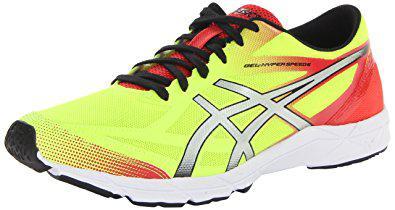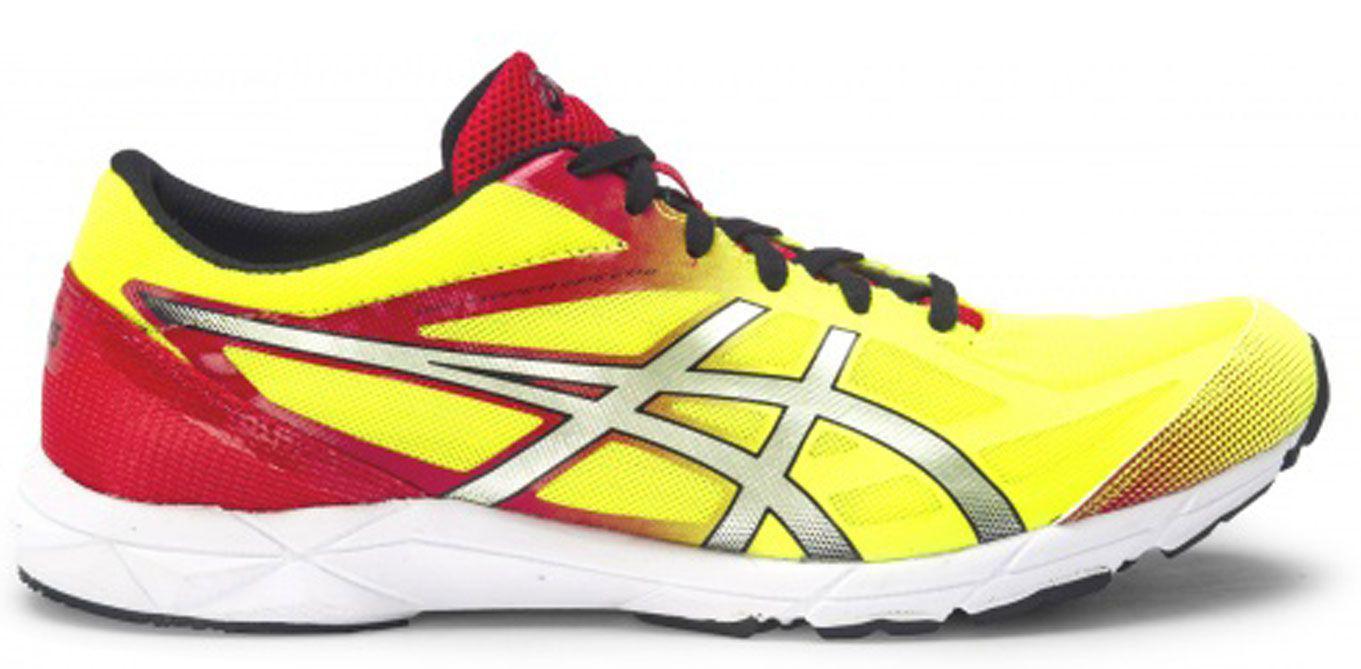The first image is the image on the left, the second image is the image on the right. Examine the images to the left and right. Is the description "The left image contains a sports show who's toe is facing towards the right." accurate? Answer yes or no. No. The first image is the image on the left, the second image is the image on the right. For the images displayed, is the sentence "Each image shows a single sneaker, and right and left images are posed heel to heel." factually correct? Answer yes or no. Yes. 